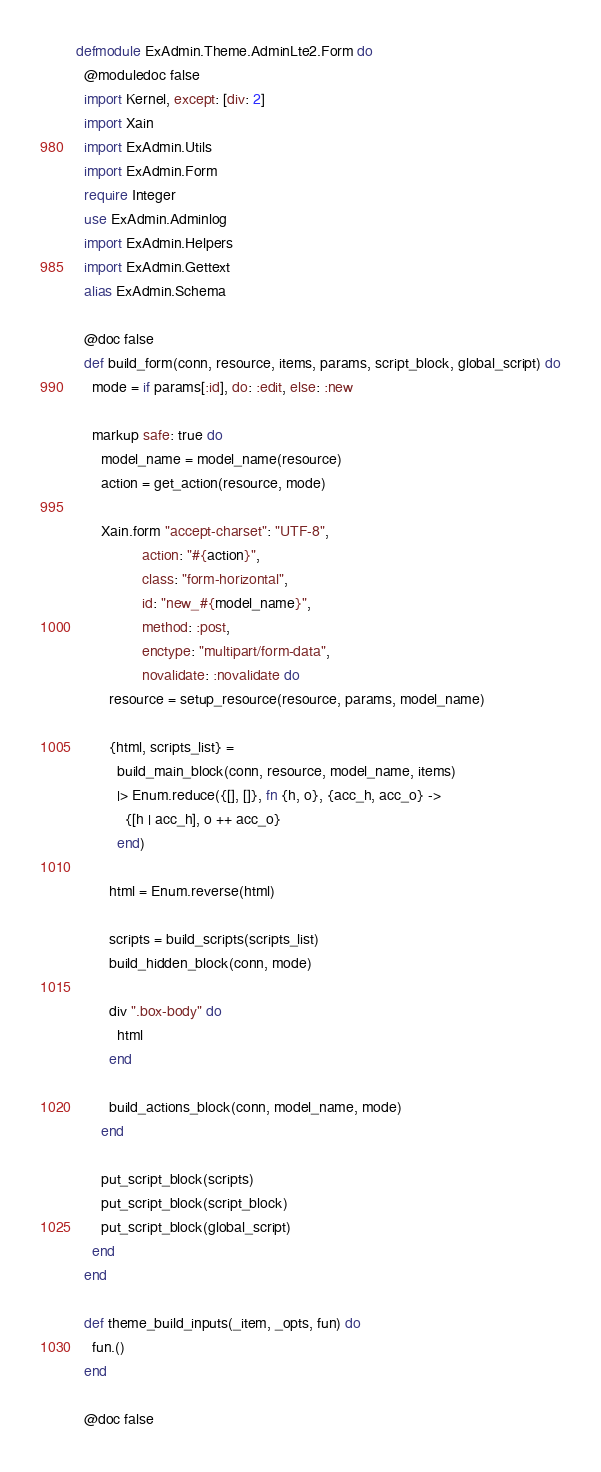Convert code to text. <code><loc_0><loc_0><loc_500><loc_500><_Elixir_>defmodule ExAdmin.Theme.AdminLte2.Form do
  @moduledoc false
  import Kernel, except: [div: 2]
  import Xain
  import ExAdmin.Utils
  import ExAdmin.Form
  require Integer
  use ExAdmin.Adminlog
  import ExAdmin.Helpers
  import ExAdmin.Gettext
  alias ExAdmin.Schema

  @doc false
  def build_form(conn, resource, items, params, script_block, global_script) do
    mode = if params[:id], do: :edit, else: :new

    markup safe: true do
      model_name = model_name(resource)
      action = get_action(resource, mode)

      Xain.form "accept-charset": "UTF-8",
                action: "#{action}",
                class: "form-horizontal",
                id: "new_#{model_name}",
                method: :post,
                enctype: "multipart/form-data",
                novalidate: :novalidate do
        resource = setup_resource(resource, params, model_name)

        {html, scripts_list} =
          build_main_block(conn, resource, model_name, items)
          |> Enum.reduce({[], []}, fn {h, o}, {acc_h, acc_o} ->
            {[h | acc_h], o ++ acc_o}
          end)

        html = Enum.reverse(html)

        scripts = build_scripts(scripts_list)
        build_hidden_block(conn, mode)

        div ".box-body" do
          html
        end

        build_actions_block(conn, model_name, mode)
      end

      put_script_block(scripts)
      put_script_block(script_block)
      put_script_block(global_script)
    end
  end

  def theme_build_inputs(_item, _opts, fun) do
    fun.()
  end

  @doc false</code> 